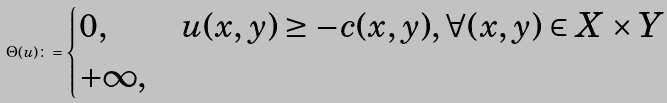<formula> <loc_0><loc_0><loc_500><loc_500>\Theta ( u ) \colon = \begin{cases} 0 , & u ( x , y ) \geq - c ( x , y ) , \forall ( x , y ) \in X \times Y \\ + \infty , & \end{cases}</formula> 